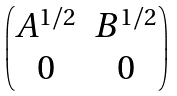<formula> <loc_0><loc_0><loc_500><loc_500>\begin{pmatrix} A ^ { 1 / 2 } & B ^ { 1 / 2 } \\ 0 & 0 \end{pmatrix}</formula> 